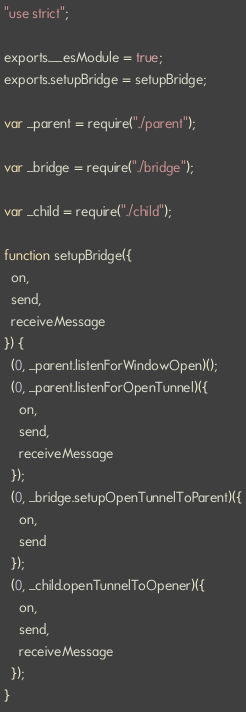<code> <loc_0><loc_0><loc_500><loc_500><_JavaScript_>"use strict";

exports.__esModule = true;
exports.setupBridge = setupBridge;

var _parent = require("./parent");

var _bridge = require("./bridge");

var _child = require("./child");

function setupBridge({
  on,
  send,
  receiveMessage
}) {
  (0, _parent.listenForWindowOpen)();
  (0, _parent.listenForOpenTunnel)({
    on,
    send,
    receiveMessage
  });
  (0, _bridge.setupOpenTunnelToParent)({
    on,
    send
  });
  (0, _child.openTunnelToOpener)({
    on,
    send,
    receiveMessage
  });
}</code> 